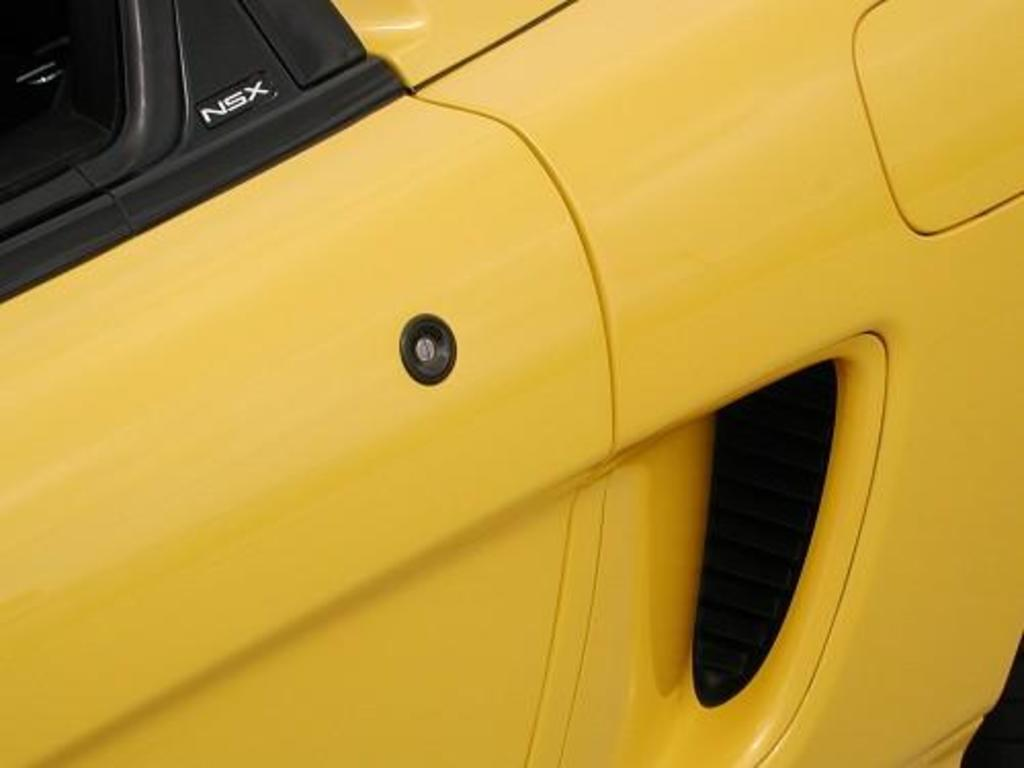What is the main subject of the image? The main subject of the image is a car. Can you describe the color of the car? The car is yellow in color. How much debt does the car have in the image? There is no information about the car's debt in the image. What is the comparison between the car and a bicycle in the image? There is no bicycle present in the image, so it is not possible to make a comparison. 